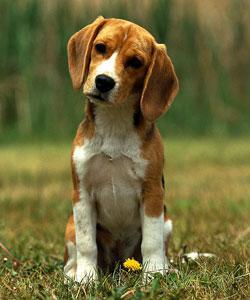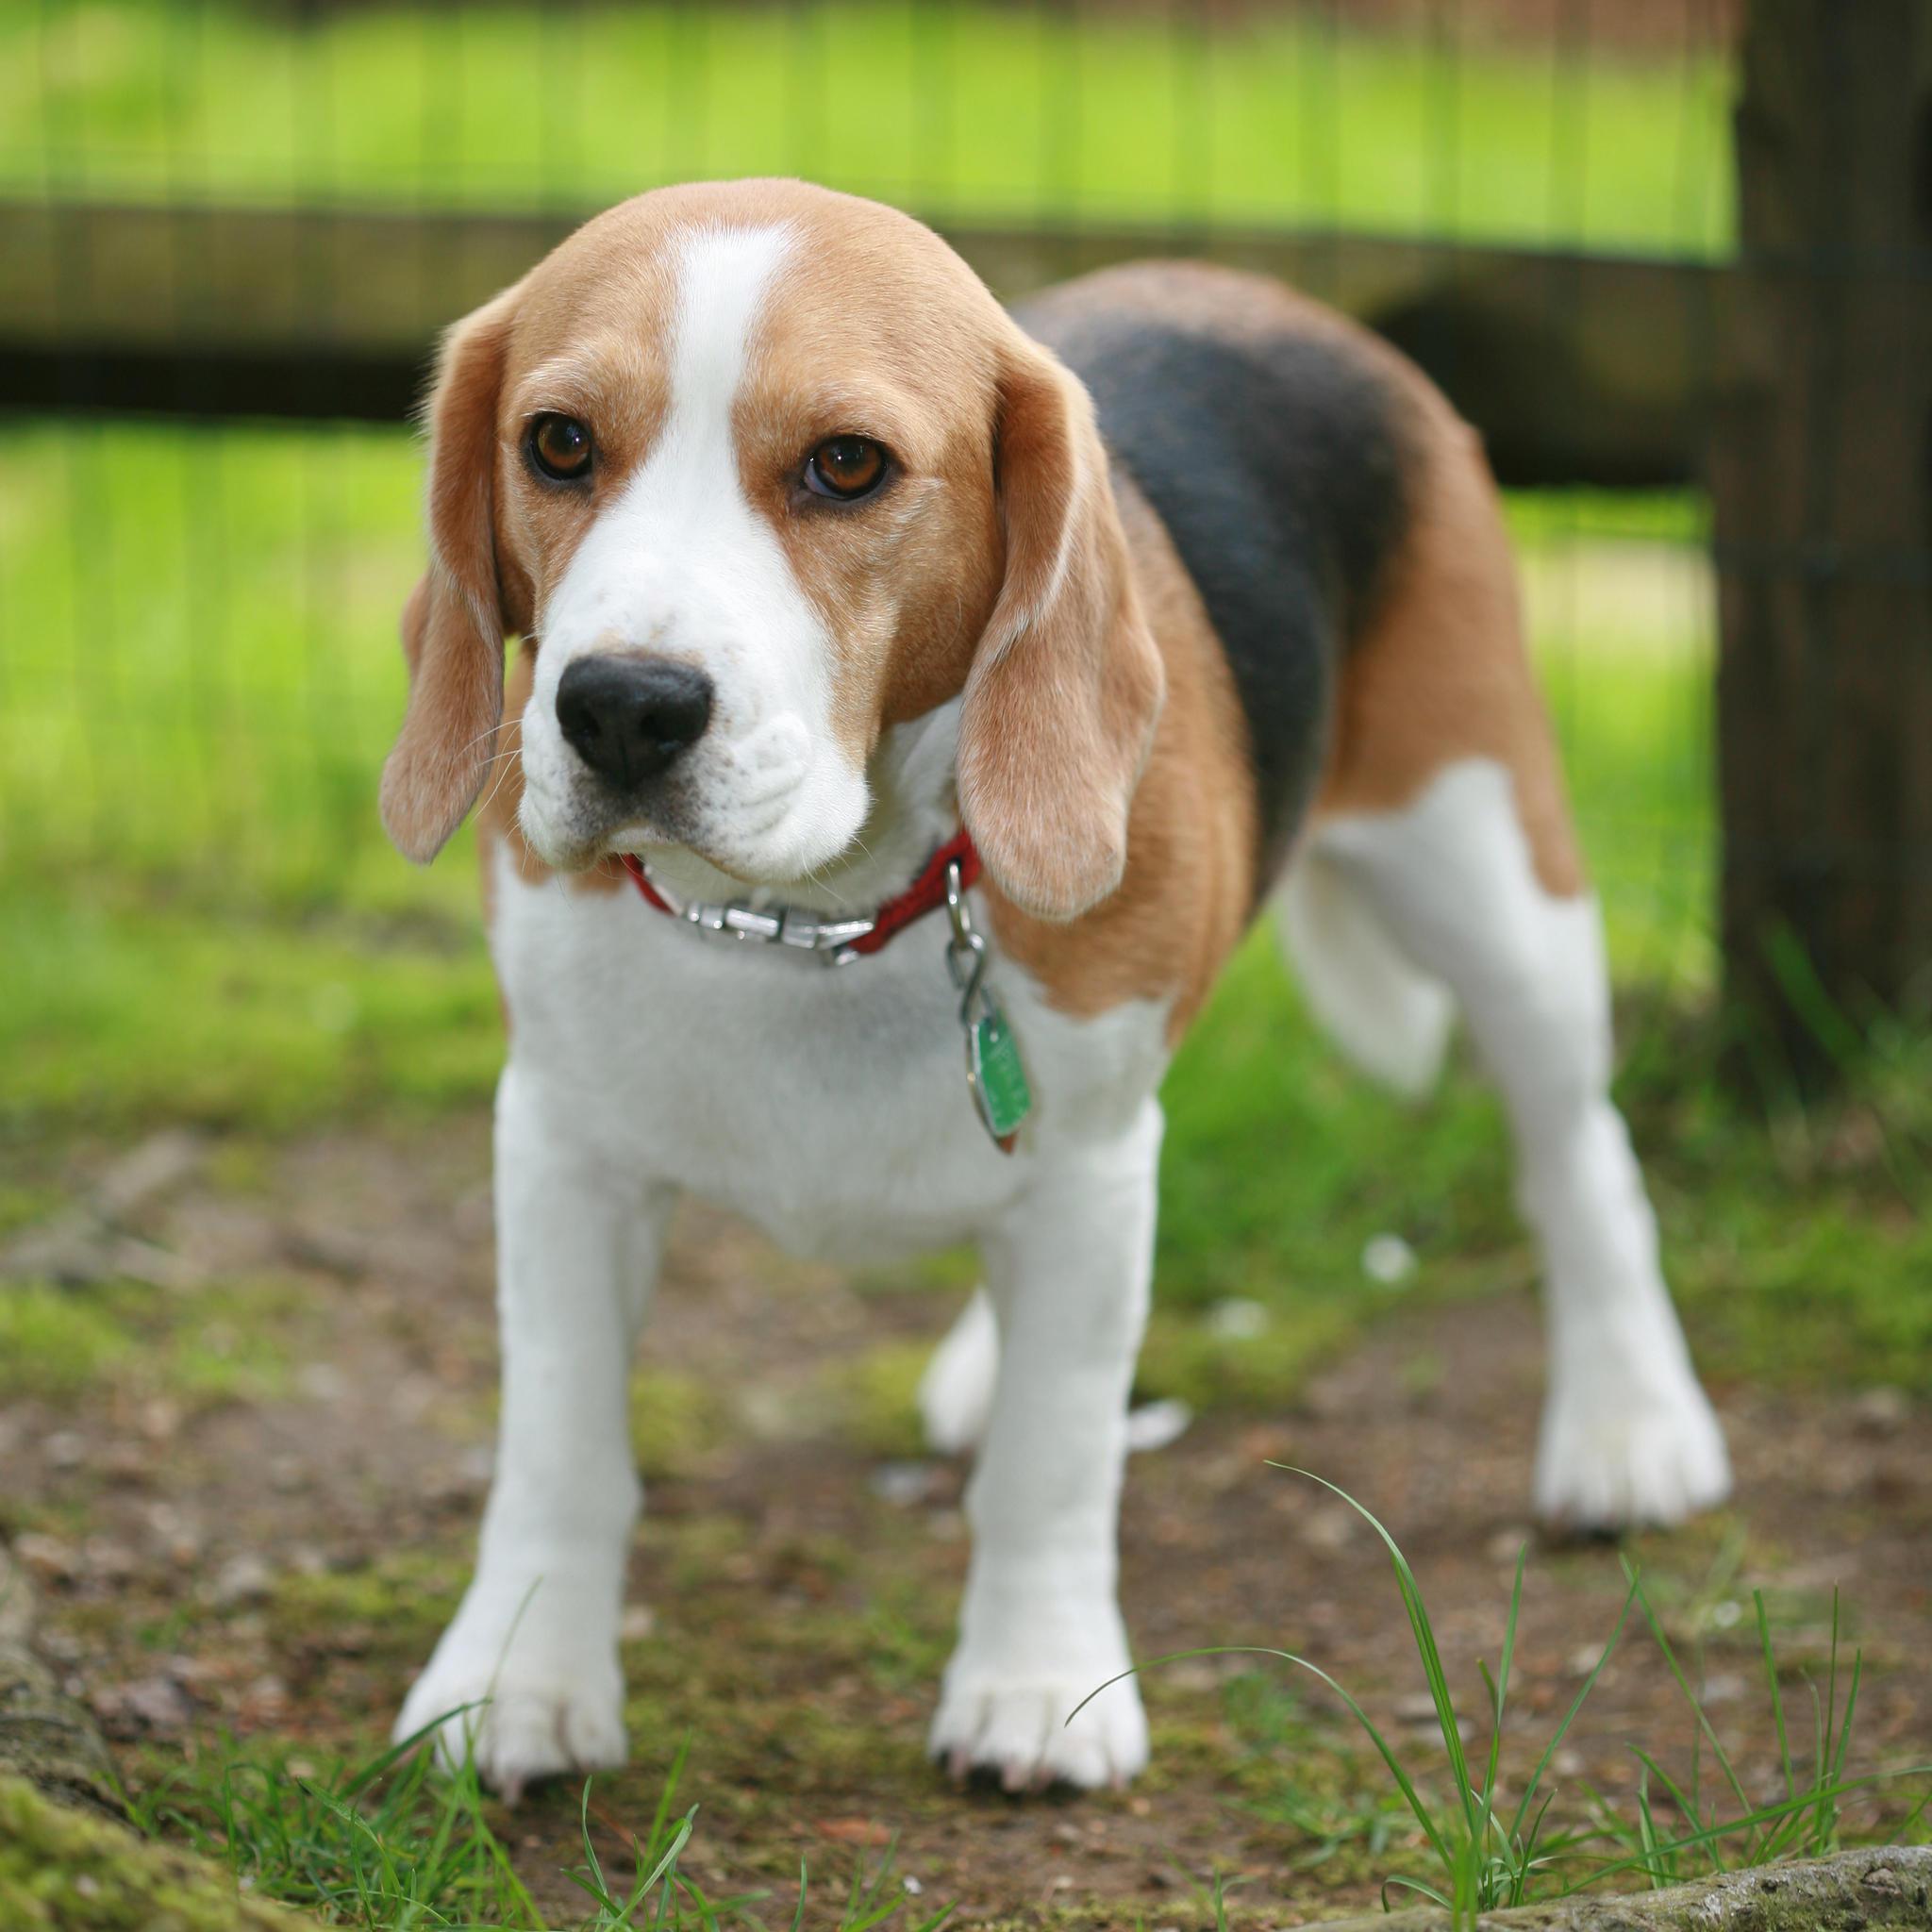The first image is the image on the left, the second image is the image on the right. Given the left and right images, does the statement "In one of the images there is a single beagle standing outside." hold true? Answer yes or no. Yes. 